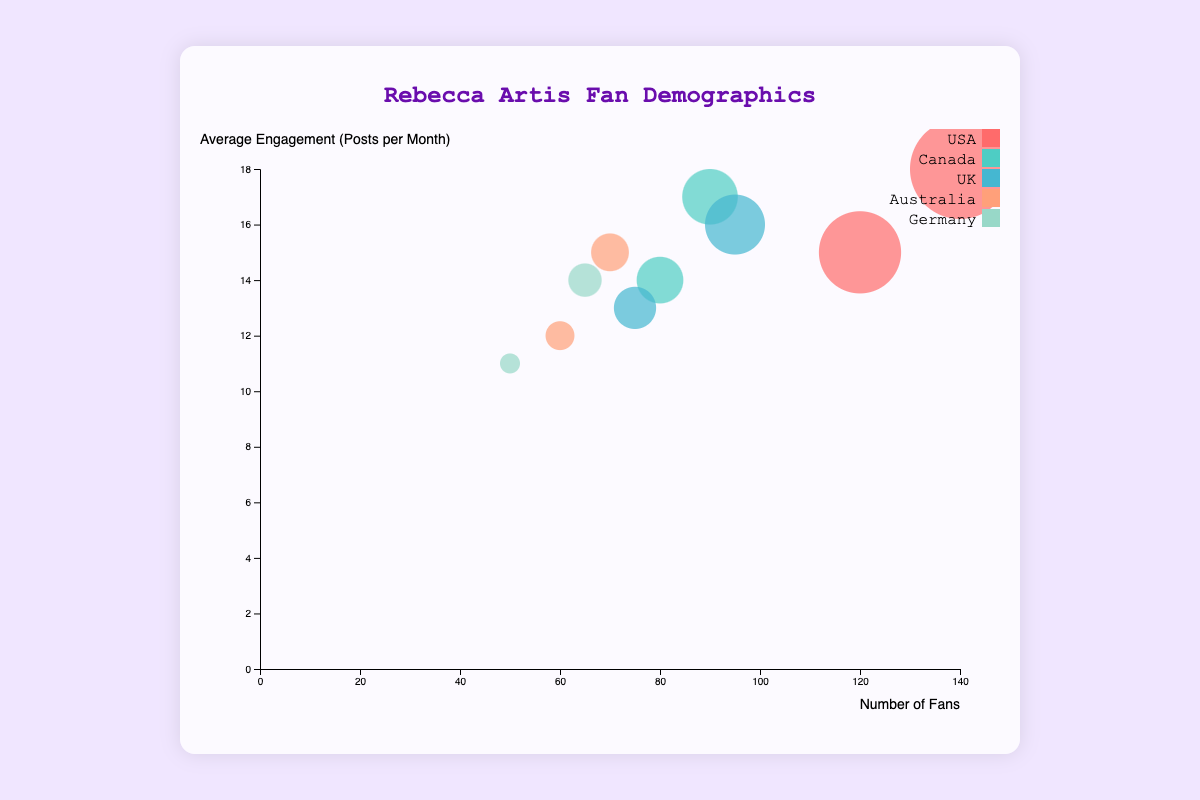How many age groups are represented in the data points? The chart shows data for two age groups (18-24 and 25-34) for each location, visible through the different bubble sizes and positions.
Answer: 2 What is the color associated with fans from Canada? By looking at the legend, fans from Canada are represented by a specific color shade.
Answer: #4ECDC4 Which location has the highest number of fans in the 18-24 age group? By comparing the bubble sizes within the 18-24 age group, it is visible that the USA has the largest bubble size, representing the highest number of fans.
Answer: USA What is the average number of fans across all locations for the 25-34 age group? To find the average, sum the number of fans for the 25-34 age group across all locations (140+90+95+70+65 = 460) and then divide by the number of locations (5).
Answer: 92 Which age group in the UK has higher average engagement? Compare the positions of the bubbles representing UK fans in both age groups. The bubble higher on the y-axis represents higher engagement.
Answer: 25-34 How does the engagement of fans in Australia compare between the two age groups? By observing the y-axis positions for Australia's bubbles, the 25-34 age group is positioned higher, indicating higher engagement.
Answer: Higher for 25-34 What is the difference in the number of fans between the USA and Germany in the 25-34 age group? Subtract the number of fans in Germany from the number of fans in the USA for the 25-34 age group (140 - 65).
Answer: 75 In which location do fans in the 18-24 age group have the lowest engagement? The engagement can be determined by the y-axis position. The bubble representing Germany is the lowest on the y-axis among 18-24 age groups.
Answer: Germany Do fans in Canada have higher engagement in the 18-24 or 25-34 age group? Compare the vertical positions of the Canadian fans’ bubbles. The bubble for the 25-34 age group is higher on the y-axis, indicating higher engagement.
Answer: 25-34 Which two locations have the closest average engagement for the 25-34 age group? Check and compare the y-axis positions of bubbles for the 25-34 age groups across all locations. Germany and Australia have bubbles at similar heights, indicating close engagement levels.
Answer: Germany and Australia 